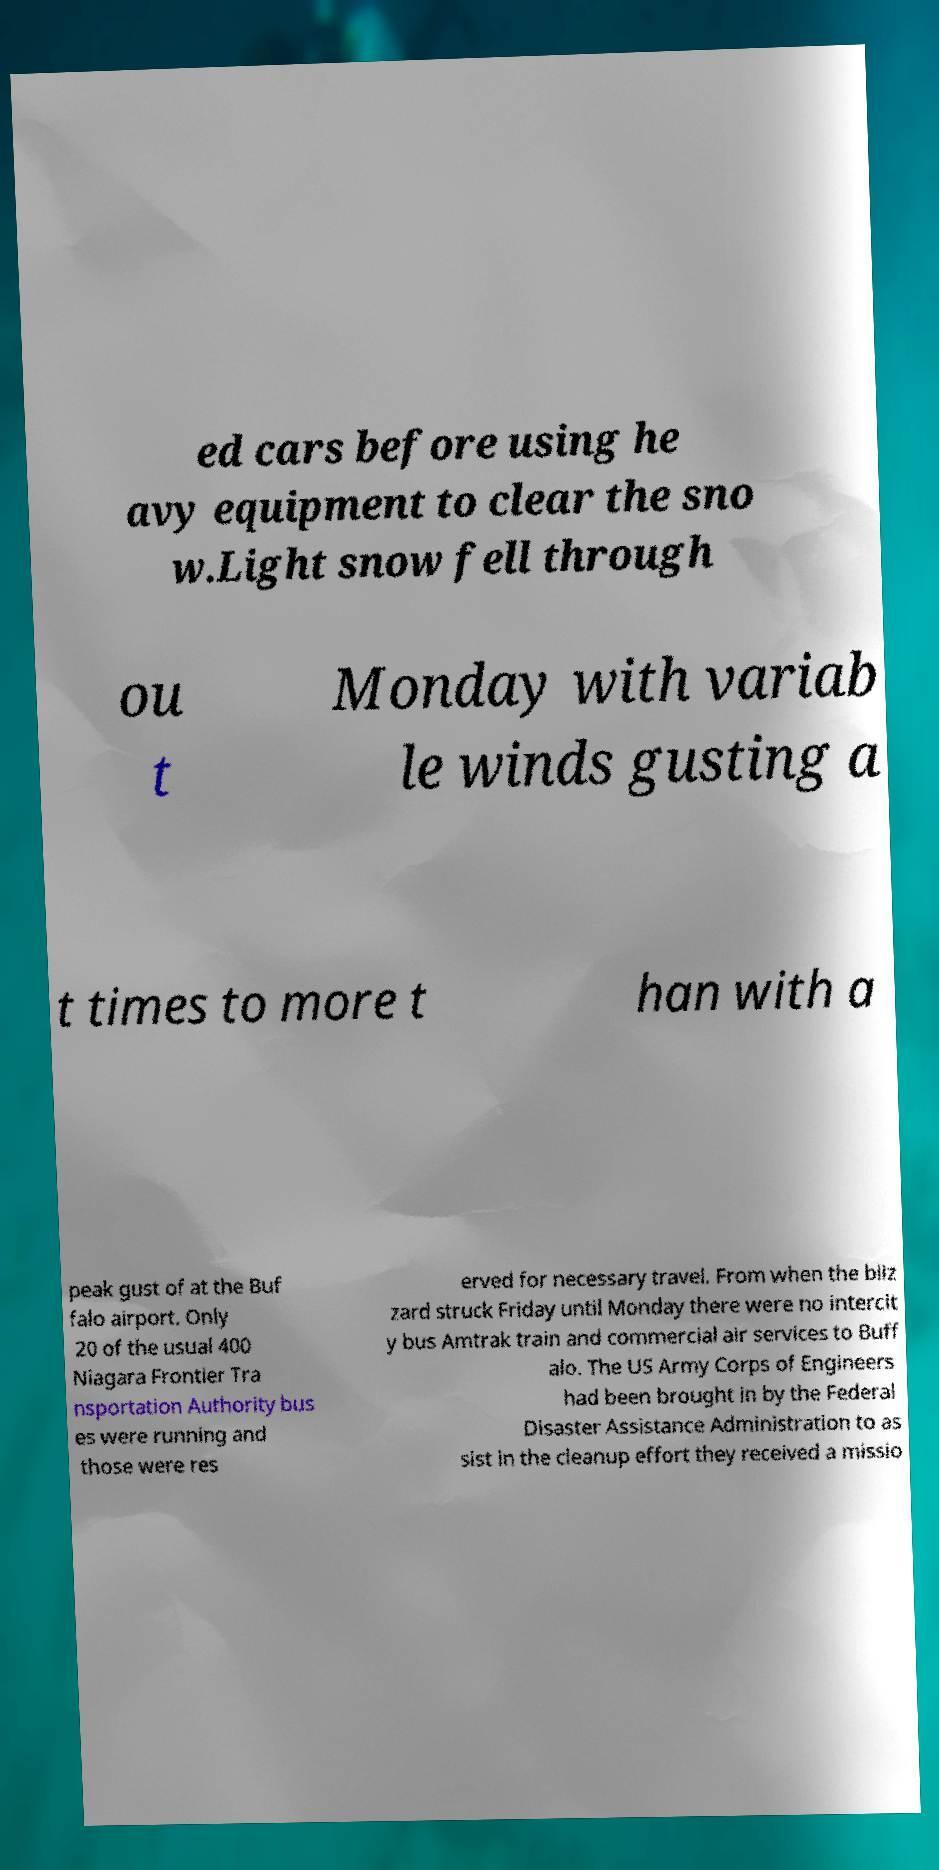Can you read and provide the text displayed in the image?This photo seems to have some interesting text. Can you extract and type it out for me? ed cars before using he avy equipment to clear the sno w.Light snow fell through ou t Monday with variab le winds gusting a t times to more t han with a peak gust of at the Buf falo airport. Only 20 of the usual 400 Niagara Frontier Tra nsportation Authority bus es were running and those were res erved for necessary travel. From when the bliz zard struck Friday until Monday there were no intercit y bus Amtrak train and commercial air services to Buff alo. The US Army Corps of Engineers had been brought in by the Federal Disaster Assistance Administration to as sist in the cleanup effort they received a missio 